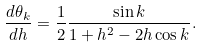<formula> <loc_0><loc_0><loc_500><loc_500>\frac { d \theta _ { k } } { d h } = \frac { 1 } { 2 } \frac { \sin k } { 1 + h ^ { 2 } - 2 h \cos k } .</formula> 